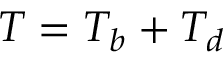Convert formula to latex. <formula><loc_0><loc_0><loc_500><loc_500>T = T _ { b } + T _ { d }</formula> 